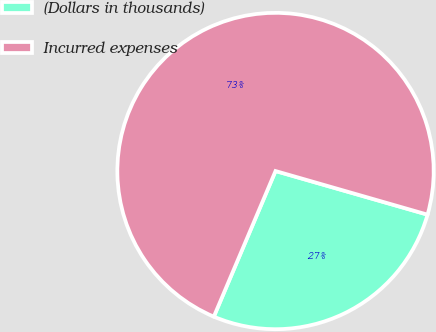Convert chart to OTSL. <chart><loc_0><loc_0><loc_500><loc_500><pie_chart><fcel>(Dollars in thousands)<fcel>Incurred expenses<nl><fcel>26.93%<fcel>73.07%<nl></chart> 